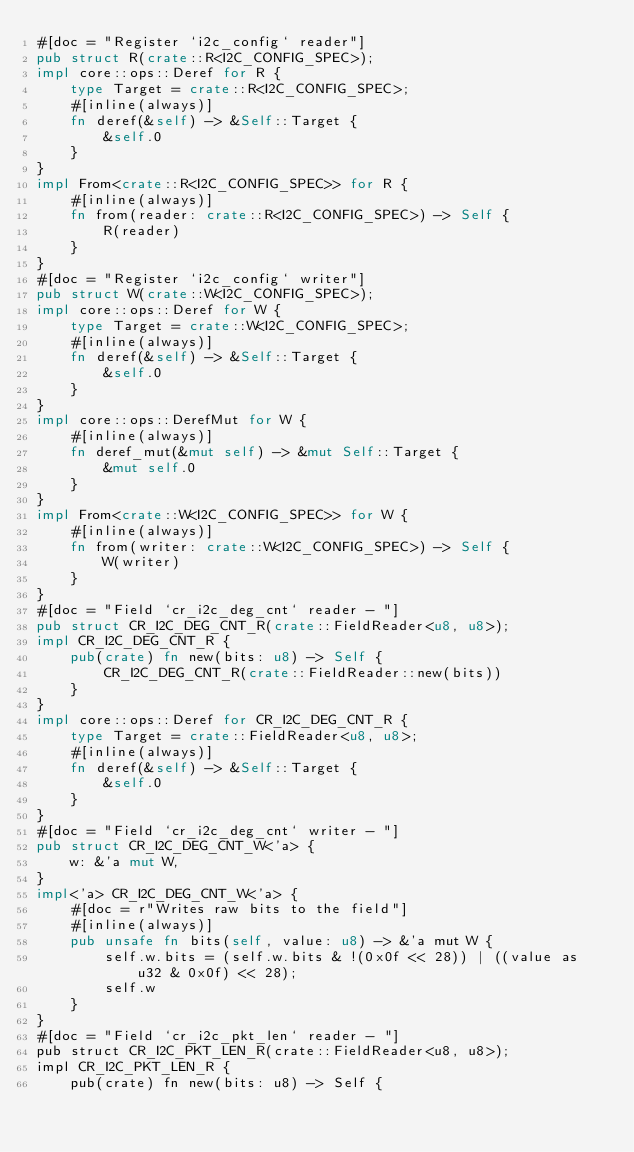Convert code to text. <code><loc_0><loc_0><loc_500><loc_500><_Rust_>#[doc = "Register `i2c_config` reader"]
pub struct R(crate::R<I2C_CONFIG_SPEC>);
impl core::ops::Deref for R {
    type Target = crate::R<I2C_CONFIG_SPEC>;
    #[inline(always)]
    fn deref(&self) -> &Self::Target {
        &self.0
    }
}
impl From<crate::R<I2C_CONFIG_SPEC>> for R {
    #[inline(always)]
    fn from(reader: crate::R<I2C_CONFIG_SPEC>) -> Self {
        R(reader)
    }
}
#[doc = "Register `i2c_config` writer"]
pub struct W(crate::W<I2C_CONFIG_SPEC>);
impl core::ops::Deref for W {
    type Target = crate::W<I2C_CONFIG_SPEC>;
    #[inline(always)]
    fn deref(&self) -> &Self::Target {
        &self.0
    }
}
impl core::ops::DerefMut for W {
    #[inline(always)]
    fn deref_mut(&mut self) -> &mut Self::Target {
        &mut self.0
    }
}
impl From<crate::W<I2C_CONFIG_SPEC>> for W {
    #[inline(always)]
    fn from(writer: crate::W<I2C_CONFIG_SPEC>) -> Self {
        W(writer)
    }
}
#[doc = "Field `cr_i2c_deg_cnt` reader - "]
pub struct CR_I2C_DEG_CNT_R(crate::FieldReader<u8, u8>);
impl CR_I2C_DEG_CNT_R {
    pub(crate) fn new(bits: u8) -> Self {
        CR_I2C_DEG_CNT_R(crate::FieldReader::new(bits))
    }
}
impl core::ops::Deref for CR_I2C_DEG_CNT_R {
    type Target = crate::FieldReader<u8, u8>;
    #[inline(always)]
    fn deref(&self) -> &Self::Target {
        &self.0
    }
}
#[doc = "Field `cr_i2c_deg_cnt` writer - "]
pub struct CR_I2C_DEG_CNT_W<'a> {
    w: &'a mut W,
}
impl<'a> CR_I2C_DEG_CNT_W<'a> {
    #[doc = r"Writes raw bits to the field"]
    #[inline(always)]
    pub unsafe fn bits(self, value: u8) -> &'a mut W {
        self.w.bits = (self.w.bits & !(0x0f << 28)) | ((value as u32 & 0x0f) << 28);
        self.w
    }
}
#[doc = "Field `cr_i2c_pkt_len` reader - "]
pub struct CR_I2C_PKT_LEN_R(crate::FieldReader<u8, u8>);
impl CR_I2C_PKT_LEN_R {
    pub(crate) fn new(bits: u8) -> Self {</code> 